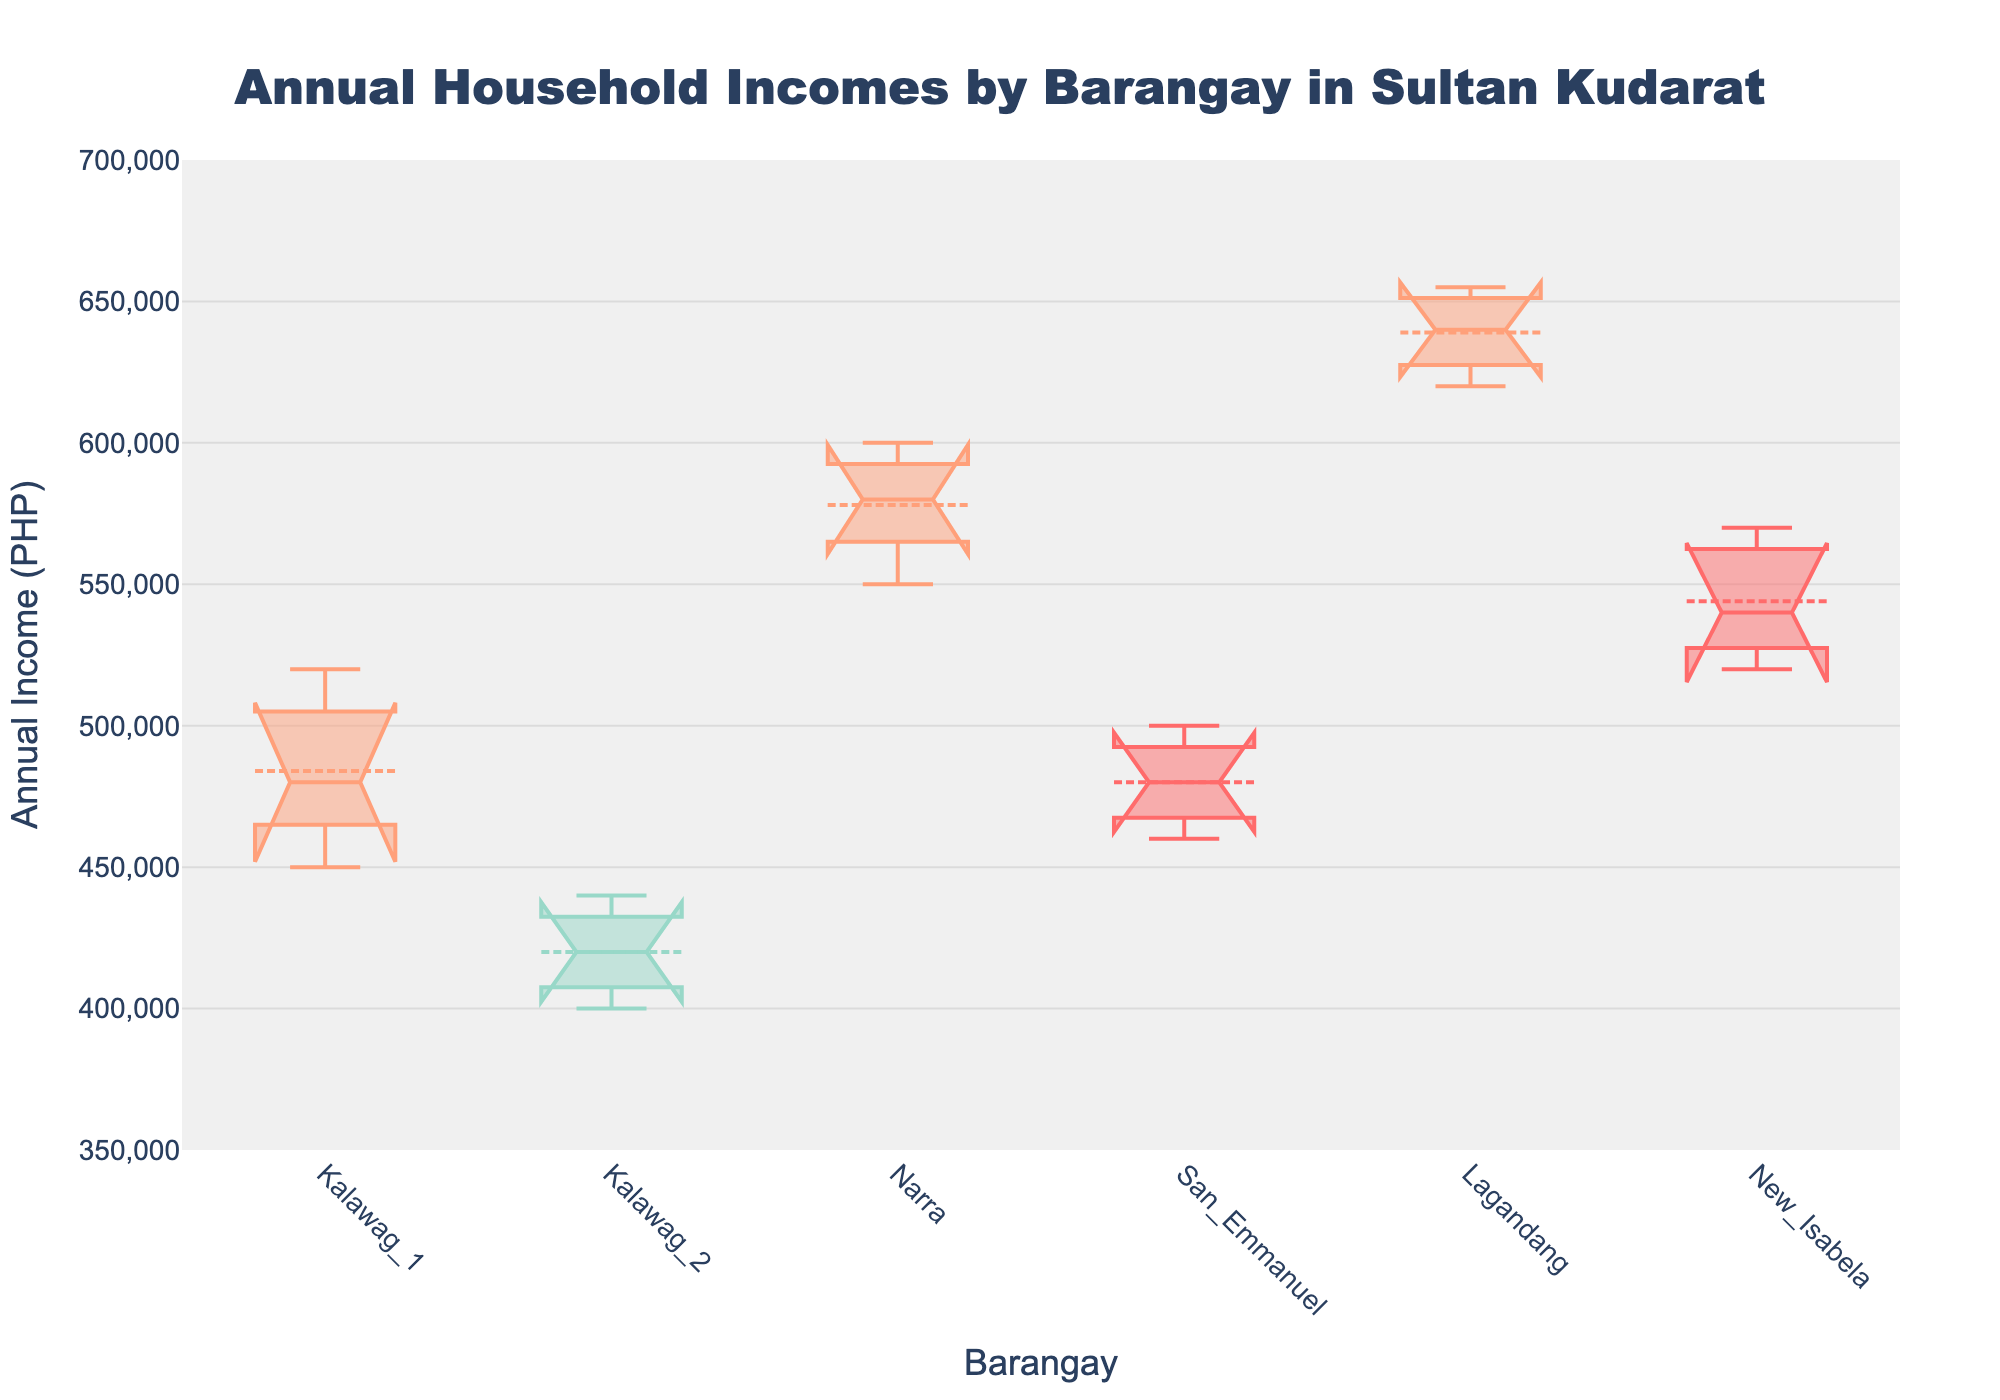Which barangay has the highest median annual income? The notched box plot shows the median values for each barangay. By comparing the median lines in the boxed areas, identify which one is highest.
Answer: Lagandang What is the interquartile range (IQR) for Narra? Calculate the IQR by subtracting the 25th percentile value (Q1) from the 75th percentile value (Q3) shown in the box plot for Narra.
Answer: 50,000 Between Kalawag_1 and San_Emmanuel, which barangay has a higher mean annual income? The box plot marks the mean with a distinct symbol (usually a dot or line). Compare the positions of these symbols between the two barangays.
Answer: Kalawag_1 How does the spread of annual incomes in New_Isabela compare to that in Kalawag_2? Compare the widths of the boxes (reflecting the interquartile range) and the lengths of the whiskers to assess the spread or variability of incomes.
Answer: New_Isabela has a wider spread What does the notch in the notched box plot signify? In the notched box plot, the notches represent the confidence interval around the median. If the notches of two boxes do not overlap, their medians are significantly different. The height of the notch is proportional to the interquartile range and the sample size.
Answer: Confidence interval around the median Which barangay shows the smallest range of annual incomes? Identify which box plot has the smallest combined length of the box and whiskers, indicating the smallest range of values.
Answer: Kalawag_2 What is the approximate median annual income for San_Emmanuel? Look at the line inside the box plot for San_Emmanuel to determine the median value.
Answer: 480,000 PHP Is there any overlap in the confidence intervals (notches) for the medians of Lagandang and Narra? Check if the notches for the two barangays' box plots overlap. If they touch or overlap, there is no significant difference between their medians at the 95% confidence level.
Answer: Yes Which barangay has the highest variability in annual incomes? Compare the lengths of the boxes and whiskers to determine which barangay has the largest total length, indicating the greatest variability.
Answer: Lagandang What does the box mean symbol represent in the notched box plot? The box mean symbol represents the mean (average) annual income for each barangay and is typically displayed as a dot or line within/on the box.
Answer: Mean annual income 